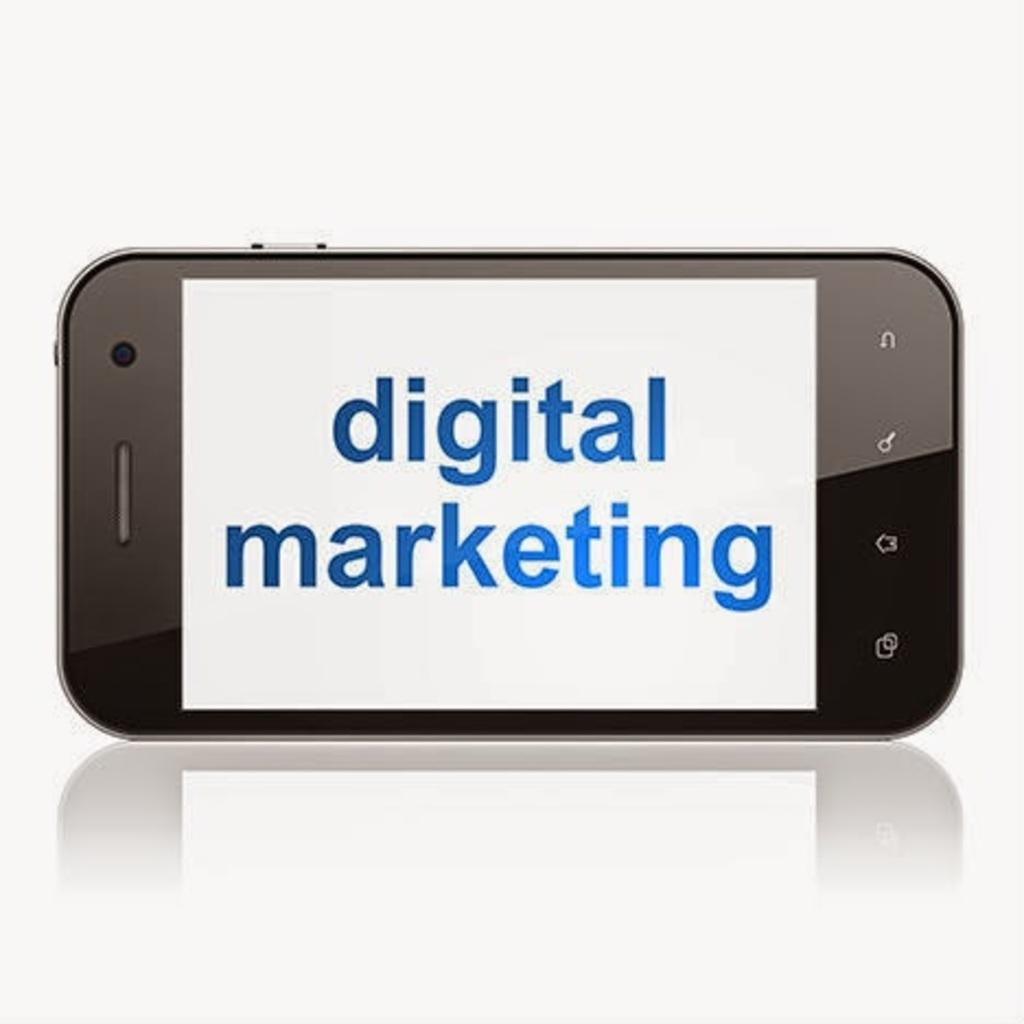Provide a one-sentence caption for the provided image. phone screen with a white background and blue words that say digital marketing. 